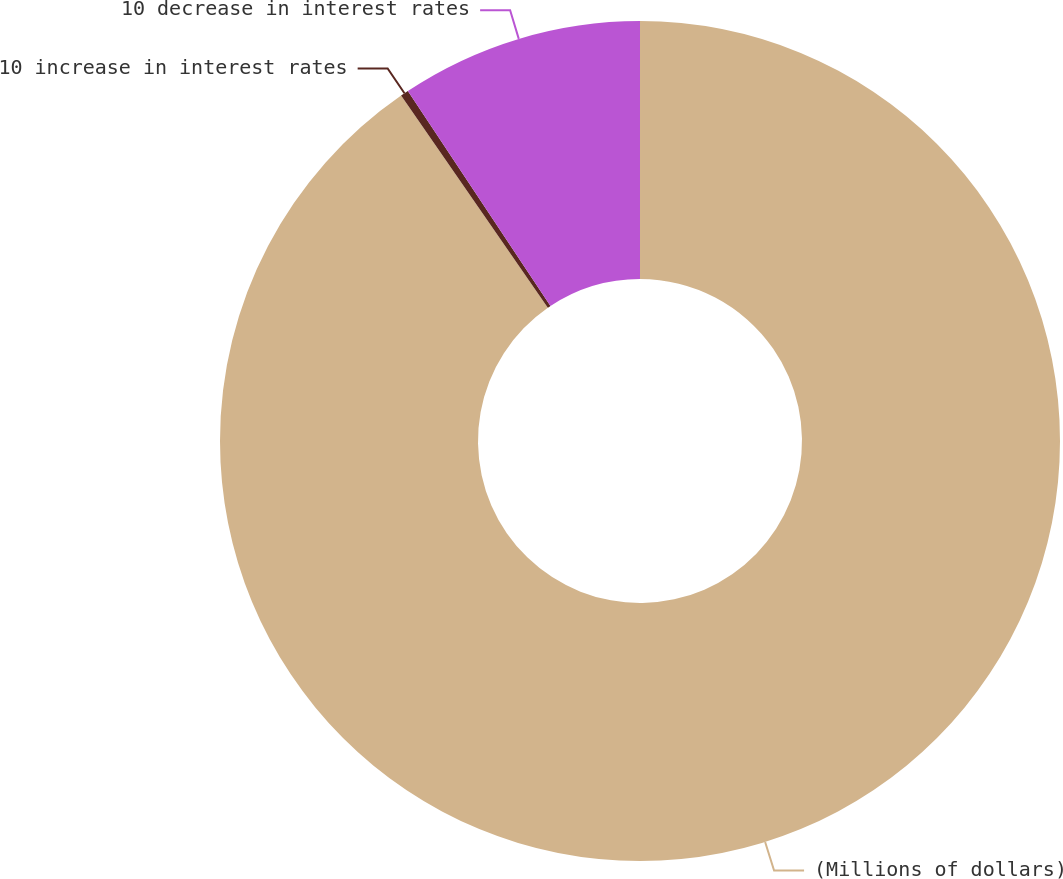Convert chart to OTSL. <chart><loc_0><loc_0><loc_500><loc_500><pie_chart><fcel>(Millions of dollars)<fcel>10 increase in interest rates<fcel>10 decrease in interest rates<nl><fcel>90.37%<fcel>0.31%<fcel>9.32%<nl></chart> 